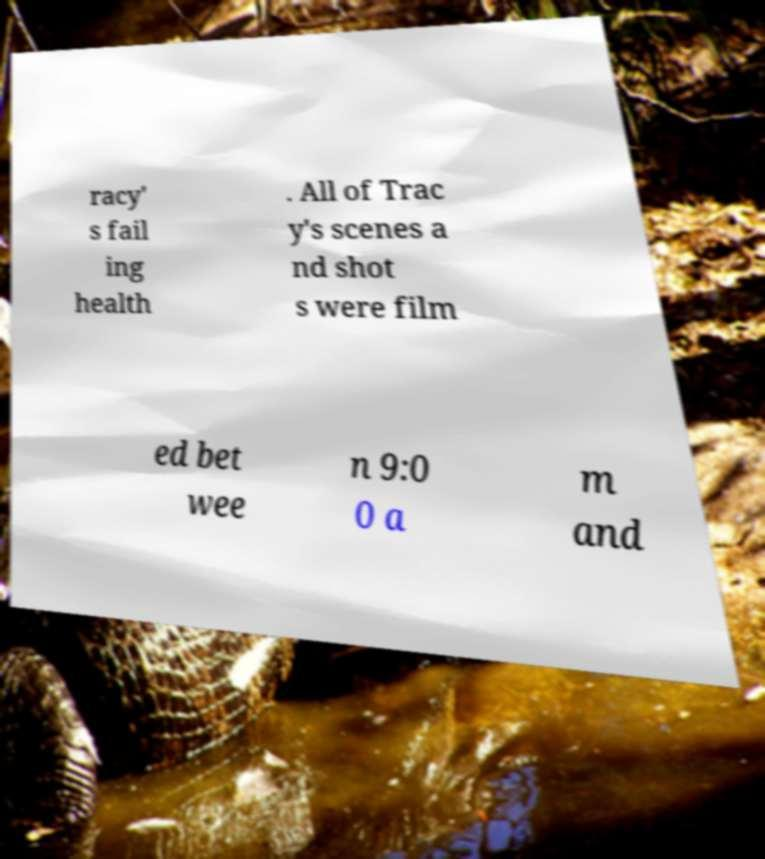Please read and relay the text visible in this image. What does it say? racy' s fail ing health . All of Trac y's scenes a nd shot s were film ed bet wee n 9:0 0 a m and 